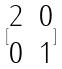Convert formula to latex. <formula><loc_0><loc_0><loc_500><loc_500>[ \begin{matrix} 2 & 0 \\ 0 & 1 \end{matrix} ]</formula> 